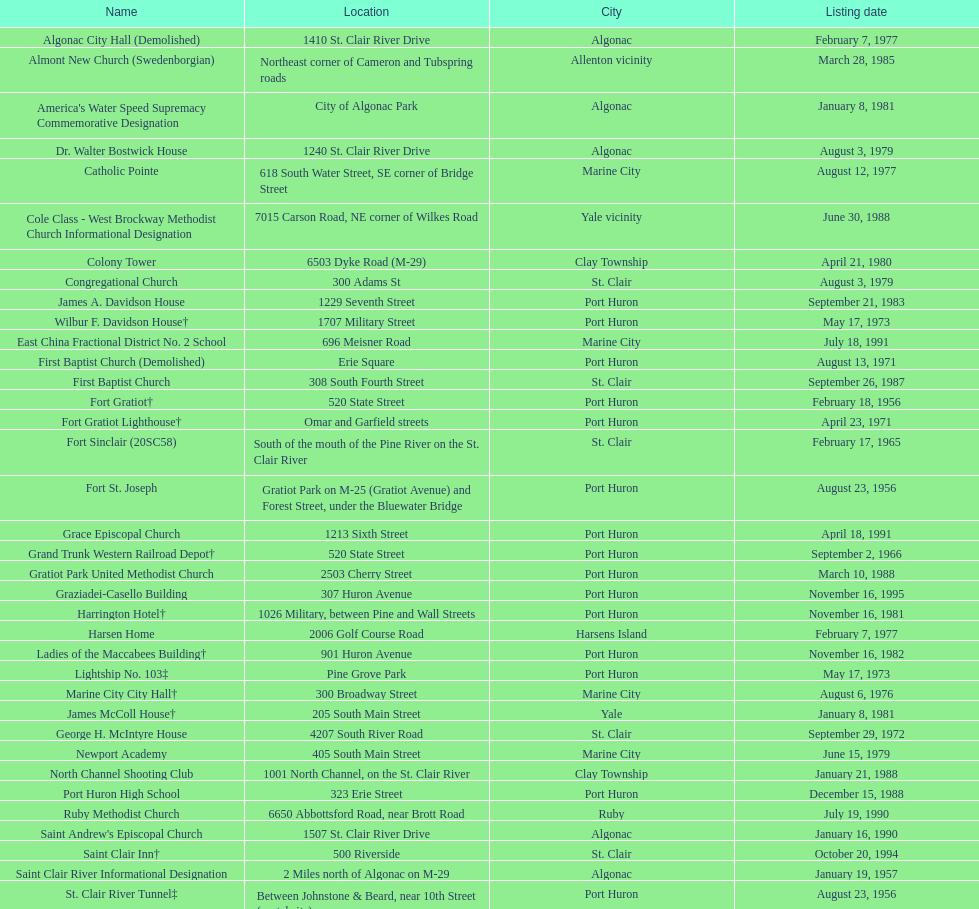Where are fort gratiot lighthouse and fort st. joseph situated in terms of city? Port Huron. 